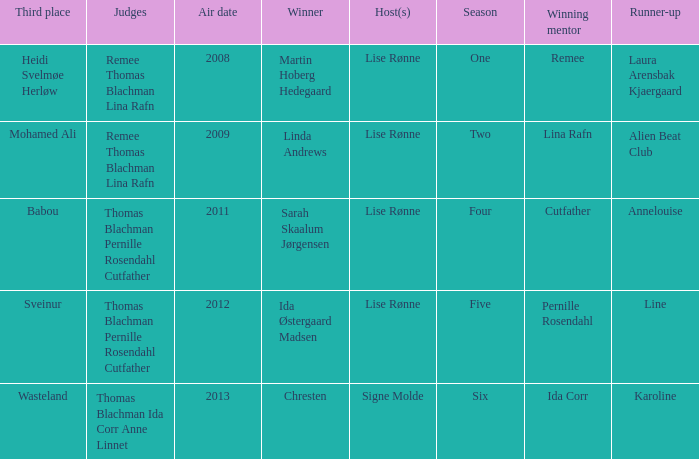Who was the runner-up in season five? Line. 